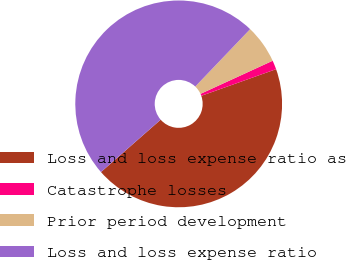Convert chart to OTSL. <chart><loc_0><loc_0><loc_500><loc_500><pie_chart><fcel>Loss and loss expense ratio as<fcel>Catastrophe losses<fcel>Prior period development<fcel>Loss and loss expense ratio<nl><fcel>43.99%<fcel>1.4%<fcel>6.01%<fcel>48.6%<nl></chart> 